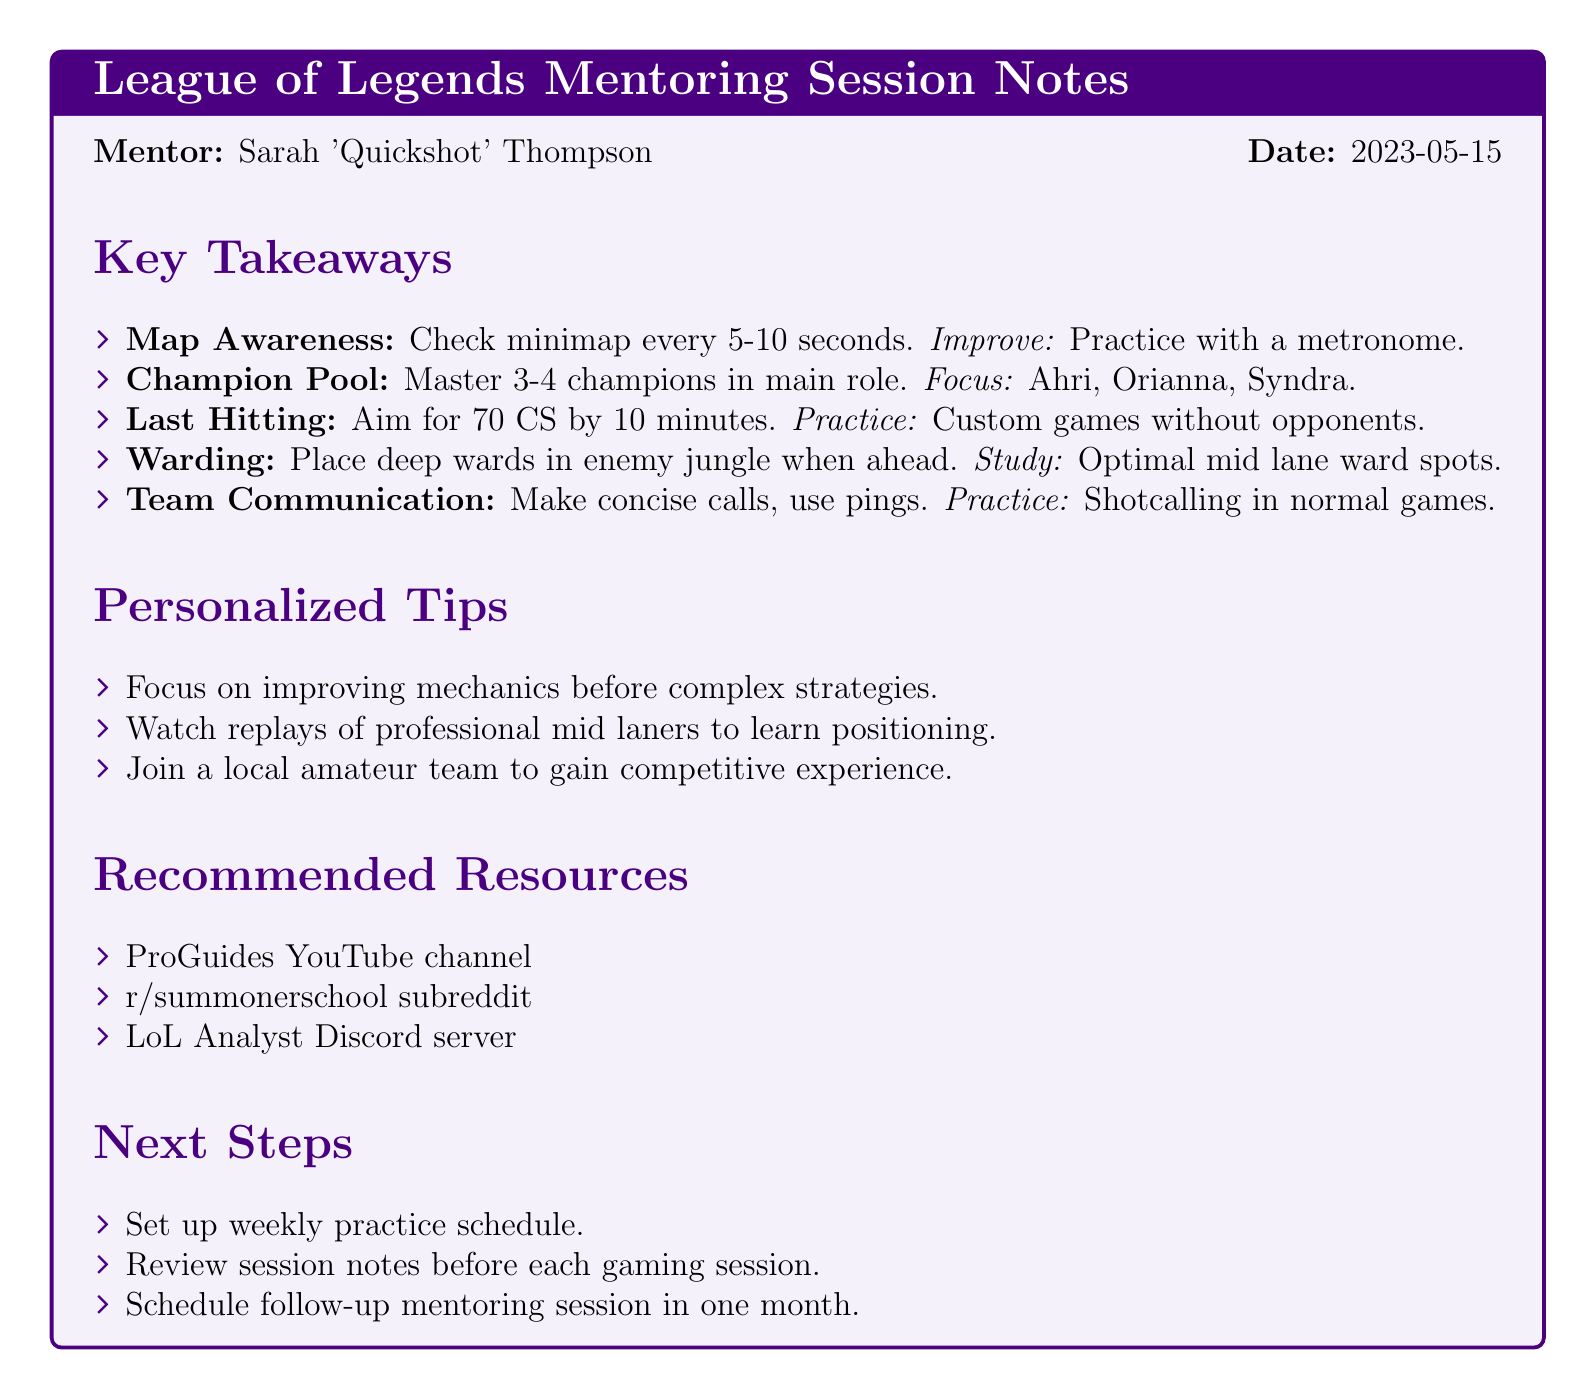What is the name of the mentor? The mentor's name is mentioned at the top of the notes as Sarah 'Quickshot' Thompson.
Answer: Sarah 'Quickshot' Thompson What game is the mentoring session about? The document specifies that the mentoring session is focused on League of Legends.
Answer: League of Legends When was the mentoring session held? The date is clearly stated in the notes as 2023-05-15.
Answer: 2023-05-15 How many champions should be mastered according to the advice? The document states that the focus should be on mastering 3-4 champions in the main role.
Answer: 3-4 What improvement area is suggested for last hitting? The document recommends practicing in custom games without opponents for improving last hitting.
Answer: Custom games without opponents What is one of the personalized tips mentioned? One of the tips suggests focusing on improving mechanics before complex strategies.
Answer: Improving mechanics before complex strategies Which social media platform is suggested as a resource? The notes recommend the r/summonerschool subreddit as a resource.
Answer: r/summonerschool subreddit What is the recommended next step regarding the practice schedule? The notes recommend setting up a weekly practice schedule as the next step.
Answer: Weekly practice schedule What is emphasized for warding when ahead? The advice suggests placing deep wards in the enemy jungle when ahead.
Answer: Place deep wards in enemy jungle 